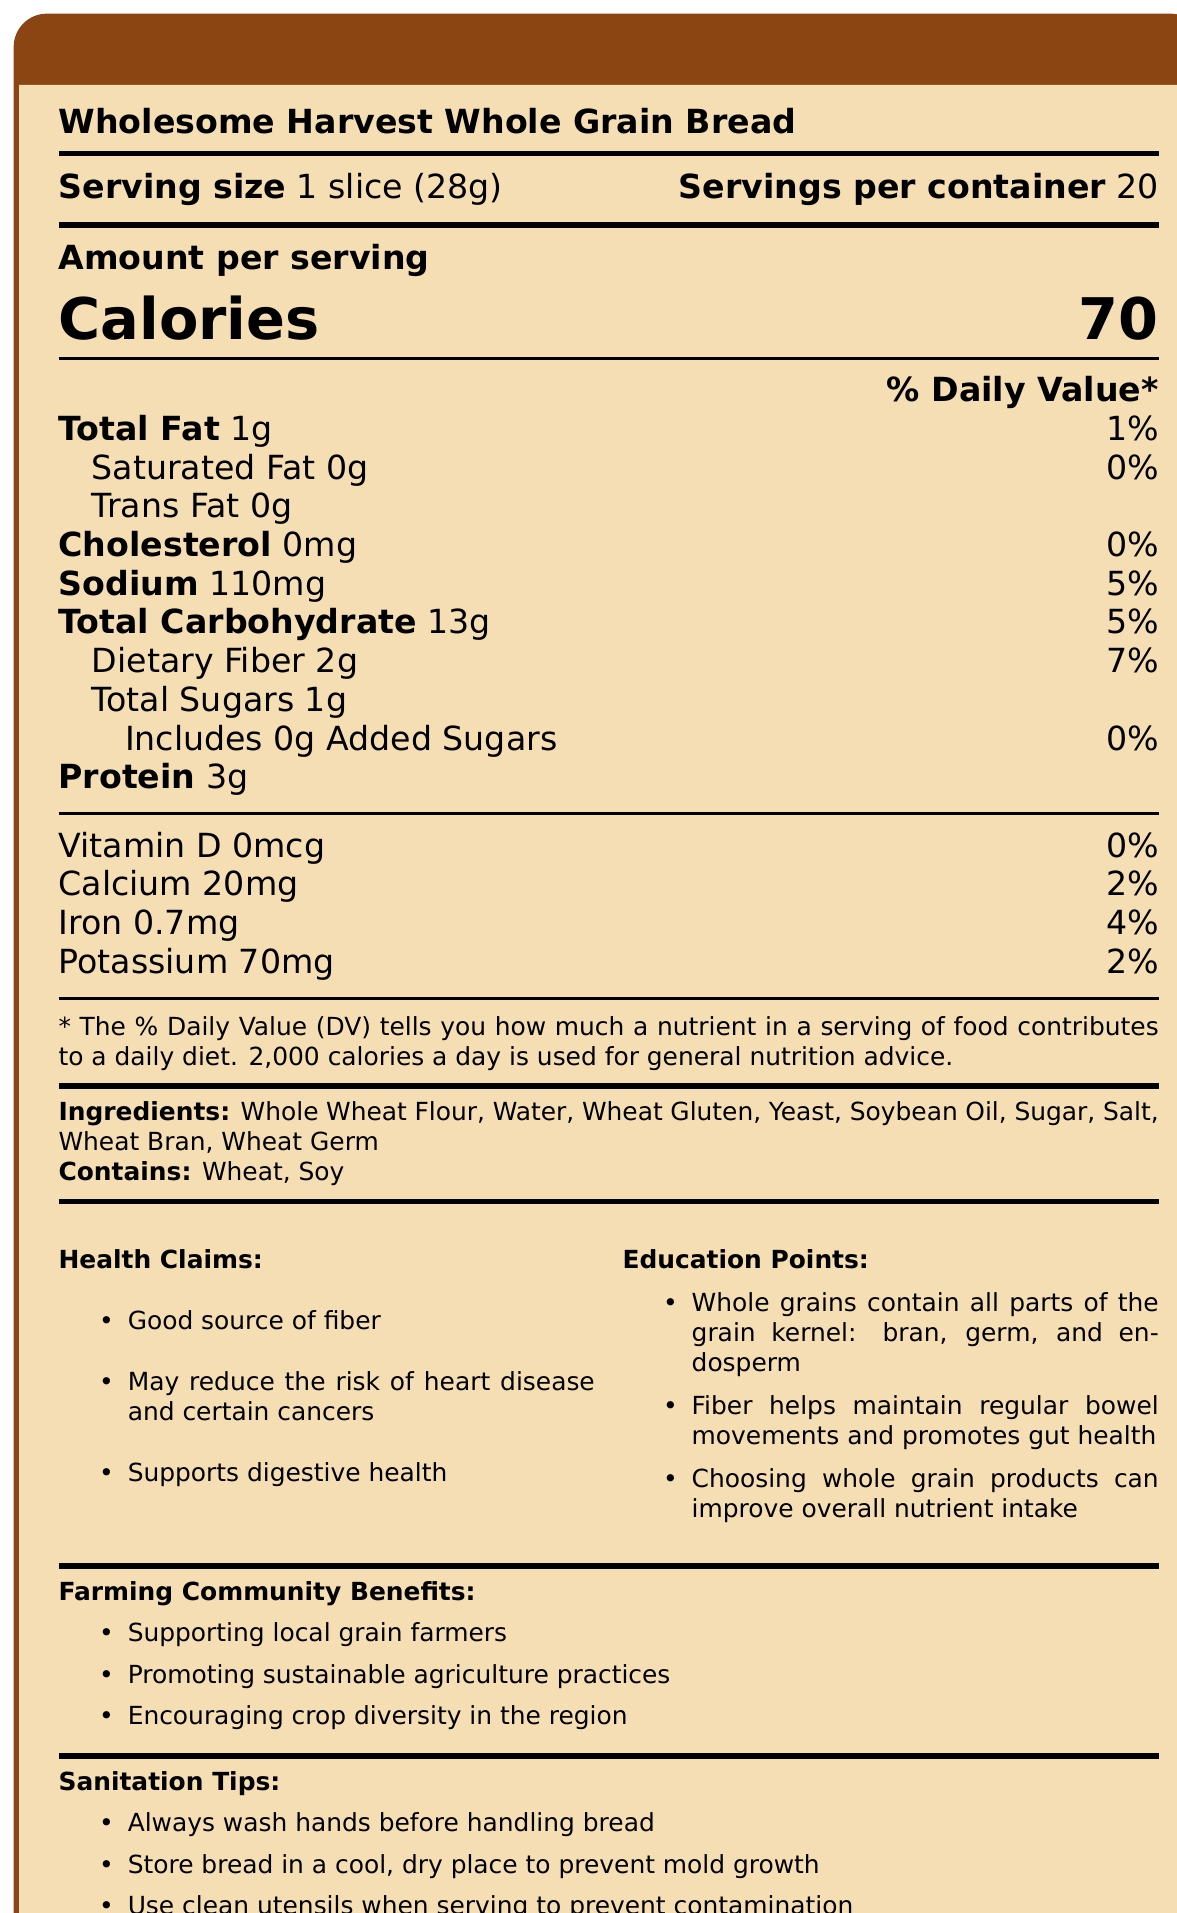what is the serving size of the bread? The serving size is clearly mentioned at the top of the document: "Serving size 1 slice (28g)".
Answer: 1 slice (28g) how many calories are there in one serving? The number of calories per serving is listed in the document: "Calories 70".
Answer: 70 calories what percentage of the daily value for dietary fiber is in one serving? The document states that dietary fiber contributes 7% of the daily value per serving.
Answer: 7% how much protein does one serving of the bread contain? The document shows that each serving contains 3g of protein.
Answer: 3g what ingredients are in the Wholesome Harvest Whole Grain Bread? The ingredients section lists all the components in the bread.
Answer: Whole Wheat Flour, Water, Wheat Gluten, Yeast, Soybean Oil, Sugar, Salt, Wheat Bran, Wheat Germ what are the health benefits mentioned in the document? A. Supports digestive health B. Promotes heart health C. May reduce the risk of certain cancers D. All of the above The document lists all these health benefits: "Supports digestive health," "May reduce the risk of heart disease and certain cancers."
Answer: D. All of the above What is the % Daily Value of sodium per serving? A. 2% B. 5% C. 7% D. 10% The document states that the sodium % Daily Value per serving is 5%.
Answer: B. 5% Does the bread contain added sugars? The document specifies that there are 0g of added sugars in the bread.
Answer: No Is this bread a good source of fiber? The document states that the bread is a "Good source of fiber."
Answer: Yes summarize the main idea of the document. The main idea centers around the nutritional content and health benefits of the bread, with a specific focus on fiber and digestive health. Additionally, it provides practical information for safe handling and storage.
Answer: This document provides the nutrition facts for Wholesome Harvest Whole Grain Bread, highlighting its fiber content and health benefits, including supporting digestive health. It also emphasizes the importance of whole grains and lists the ingredients, allergens, and sanitation tips for handling the bread. How much Vitamin D is present in one serving of the bread? The document states that there is 0mcg of Vitamin D per serving, but it does not provide further details about any possible sources or benefits related to Vitamin D.
Answer: I don't know why is it important to choose whole grain products? The document's education points mention that whole grains retain all parts of the grain kernel and improve nutrient intake.
Answer: Whole grain products improve overall nutrient intake and contain all parts of the grain kernel: bran, germ, and endosperm. How can supporting local grain farmers benefit the community? The document mentions that supporting local farmers boosts sustainable practices and crop diversity, which are beneficial for the community.
Answer: It promotes sustainable agriculture practices and encourages crop diversity in the region. 